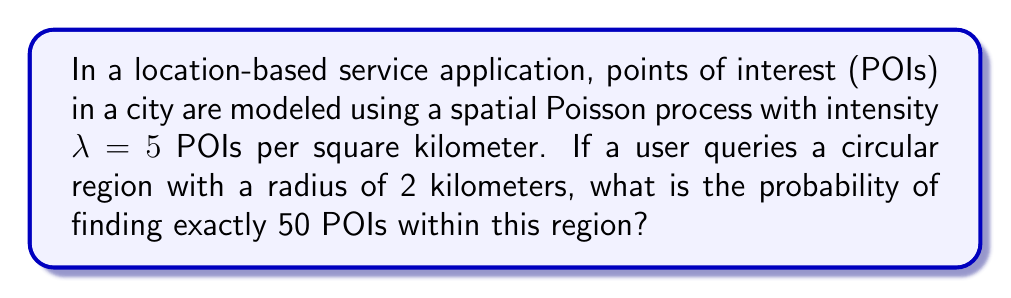Teach me how to tackle this problem. To solve this problem, we'll follow these steps:

1) First, we need to calculate the area of the circular region:
   $$A = \pi r^2 = \pi (2 \text{ km})^2 = 4\pi \text{ km}^2$$

2) In a Poisson process, the number of events (POIs in this case) in a region follows a Poisson distribution. The mean of this distribution is the product of the intensity and the area:
   $$\mu = \lambda A = 5 \text{ POIs/km}^2 \cdot 4\pi \text{ km}^2 = 20\pi \text{ POIs}$$

3) The probability of finding exactly $k$ POIs in a region where the mean is $\mu$ is given by the Poisson probability mass function:
   $$P(X = k) = \frac{e^{-\mu} \mu^k}{k!}$$

4) In our case, $k = 50$ and $\mu = 20\pi$. Substituting these values:
   $$P(X = 50) = \frac{e^{-20\pi} (20\pi)^{50}}{50!}$$

5) Using a calculator or computer to evaluate this expression:
   $$P(X = 50) \approx 0.0168$$

This means there's about a 1.68% chance of finding exactly 50 POIs in the queried region.
Answer: 0.0168 